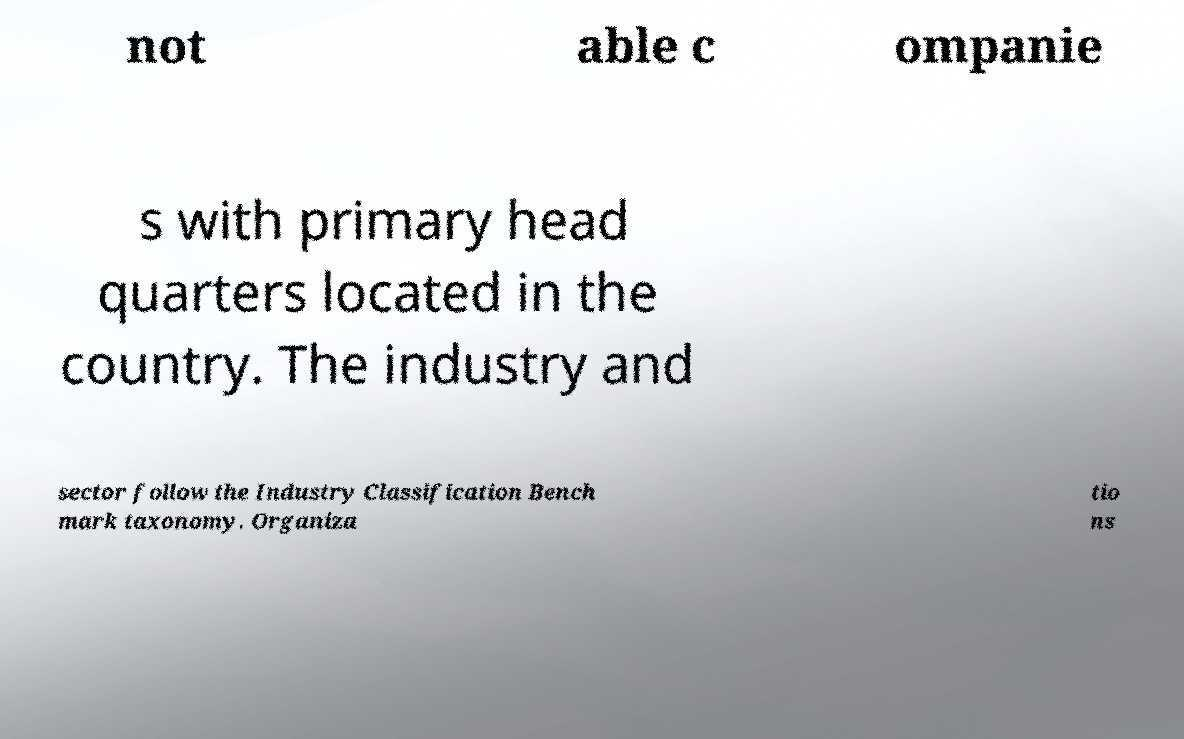Could you extract and type out the text from this image? not able c ompanie s with primary head quarters located in the country. The industry and sector follow the Industry Classification Bench mark taxonomy. Organiza tio ns 